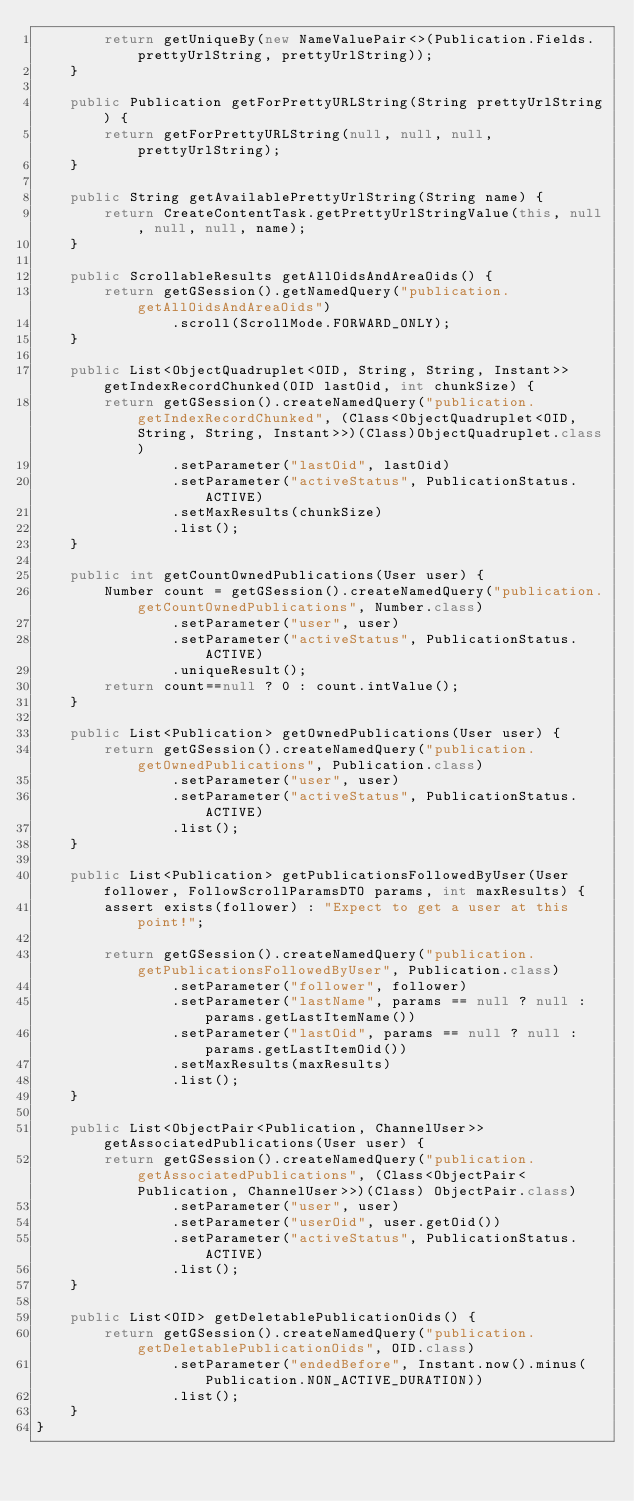<code> <loc_0><loc_0><loc_500><loc_500><_Java_>        return getUniqueBy(new NameValuePair<>(Publication.Fields.prettyUrlString, prettyUrlString));
    }

    public Publication getForPrettyURLString(String prettyUrlString) {
        return getForPrettyURLString(null, null, null, prettyUrlString);
    }

    public String getAvailablePrettyUrlString(String name) {
        return CreateContentTask.getPrettyUrlStringValue(this, null, null, null, name);
    }

    public ScrollableResults getAllOidsAndAreaOids() {
        return getGSession().getNamedQuery("publication.getAllOidsAndAreaOids")
                .scroll(ScrollMode.FORWARD_ONLY);
    }

    public List<ObjectQuadruplet<OID, String, String, Instant>> getIndexRecordChunked(OID lastOid, int chunkSize) {
        return getGSession().createNamedQuery("publication.getIndexRecordChunked", (Class<ObjectQuadruplet<OID, String, String, Instant>>)(Class)ObjectQuadruplet.class)
                .setParameter("lastOid", lastOid)
                .setParameter("activeStatus", PublicationStatus.ACTIVE)
                .setMaxResults(chunkSize)
                .list();
    }

    public int getCountOwnedPublications(User user) {
        Number count = getGSession().createNamedQuery("publication.getCountOwnedPublications", Number.class)
                .setParameter("user", user)
                .setParameter("activeStatus", PublicationStatus.ACTIVE)
                .uniqueResult();
        return count==null ? 0 : count.intValue();
    }

    public List<Publication> getOwnedPublications(User user) {
        return getGSession().createNamedQuery("publication.getOwnedPublications", Publication.class)
                .setParameter("user", user)
                .setParameter("activeStatus", PublicationStatus.ACTIVE)
                .list();
    }

    public List<Publication> getPublicationsFollowedByUser(User follower, FollowScrollParamsDTO params, int maxResults) {
        assert exists(follower) : "Expect to get a user at this point!";

        return getGSession().createNamedQuery("publication.getPublicationsFollowedByUser", Publication.class)
                .setParameter("follower", follower)
                .setParameter("lastName", params == null ? null : params.getLastItemName())
                .setParameter("lastOid", params == null ? null : params.getLastItemOid())
                .setMaxResults(maxResults)
                .list();
    }

    public List<ObjectPair<Publication, ChannelUser>> getAssociatedPublications(User user) {
        return getGSession().createNamedQuery("publication.getAssociatedPublications", (Class<ObjectPair<Publication, ChannelUser>>)(Class) ObjectPair.class)
                .setParameter("user", user)
                .setParameter("userOid", user.getOid())
                .setParameter("activeStatus", PublicationStatus.ACTIVE)
                .list();
    }

    public List<OID> getDeletablePublicationOids() {
        return getGSession().createNamedQuery("publication.getDeletablePublicationOids", OID.class)
                .setParameter("endedBefore", Instant.now().minus(Publication.NON_ACTIVE_DURATION))
                .list();
    }
}
</code> 